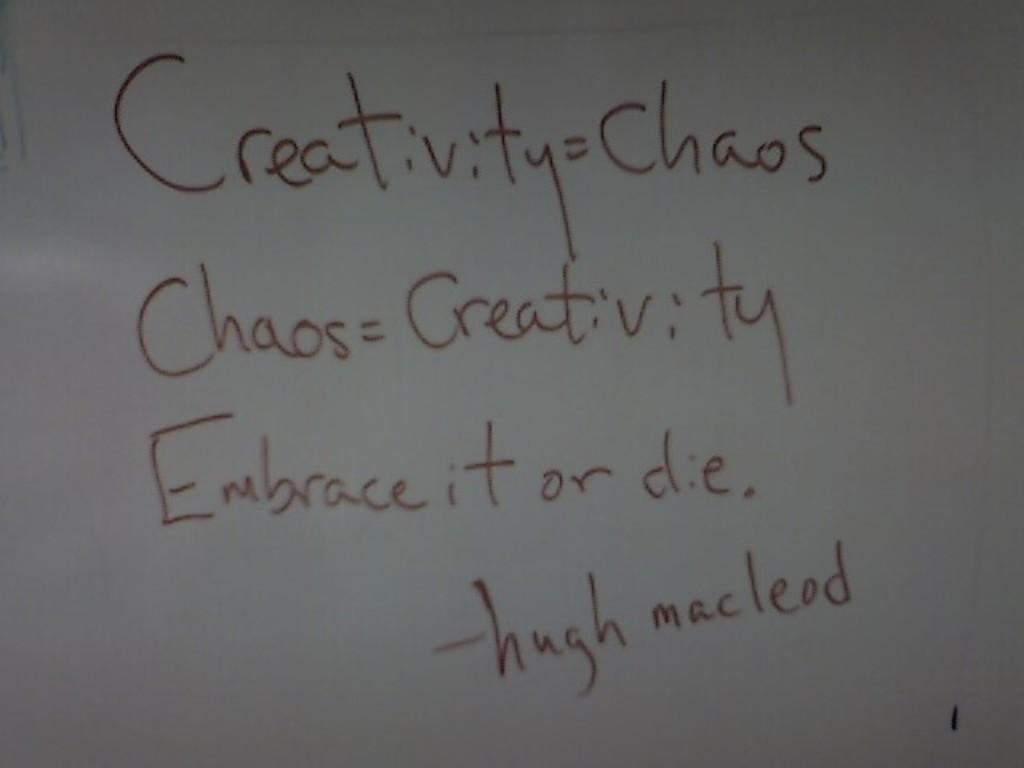<image>
Present a compact description of the photo's key features. A Hugh Macleod quotation written on a whiteboard. 